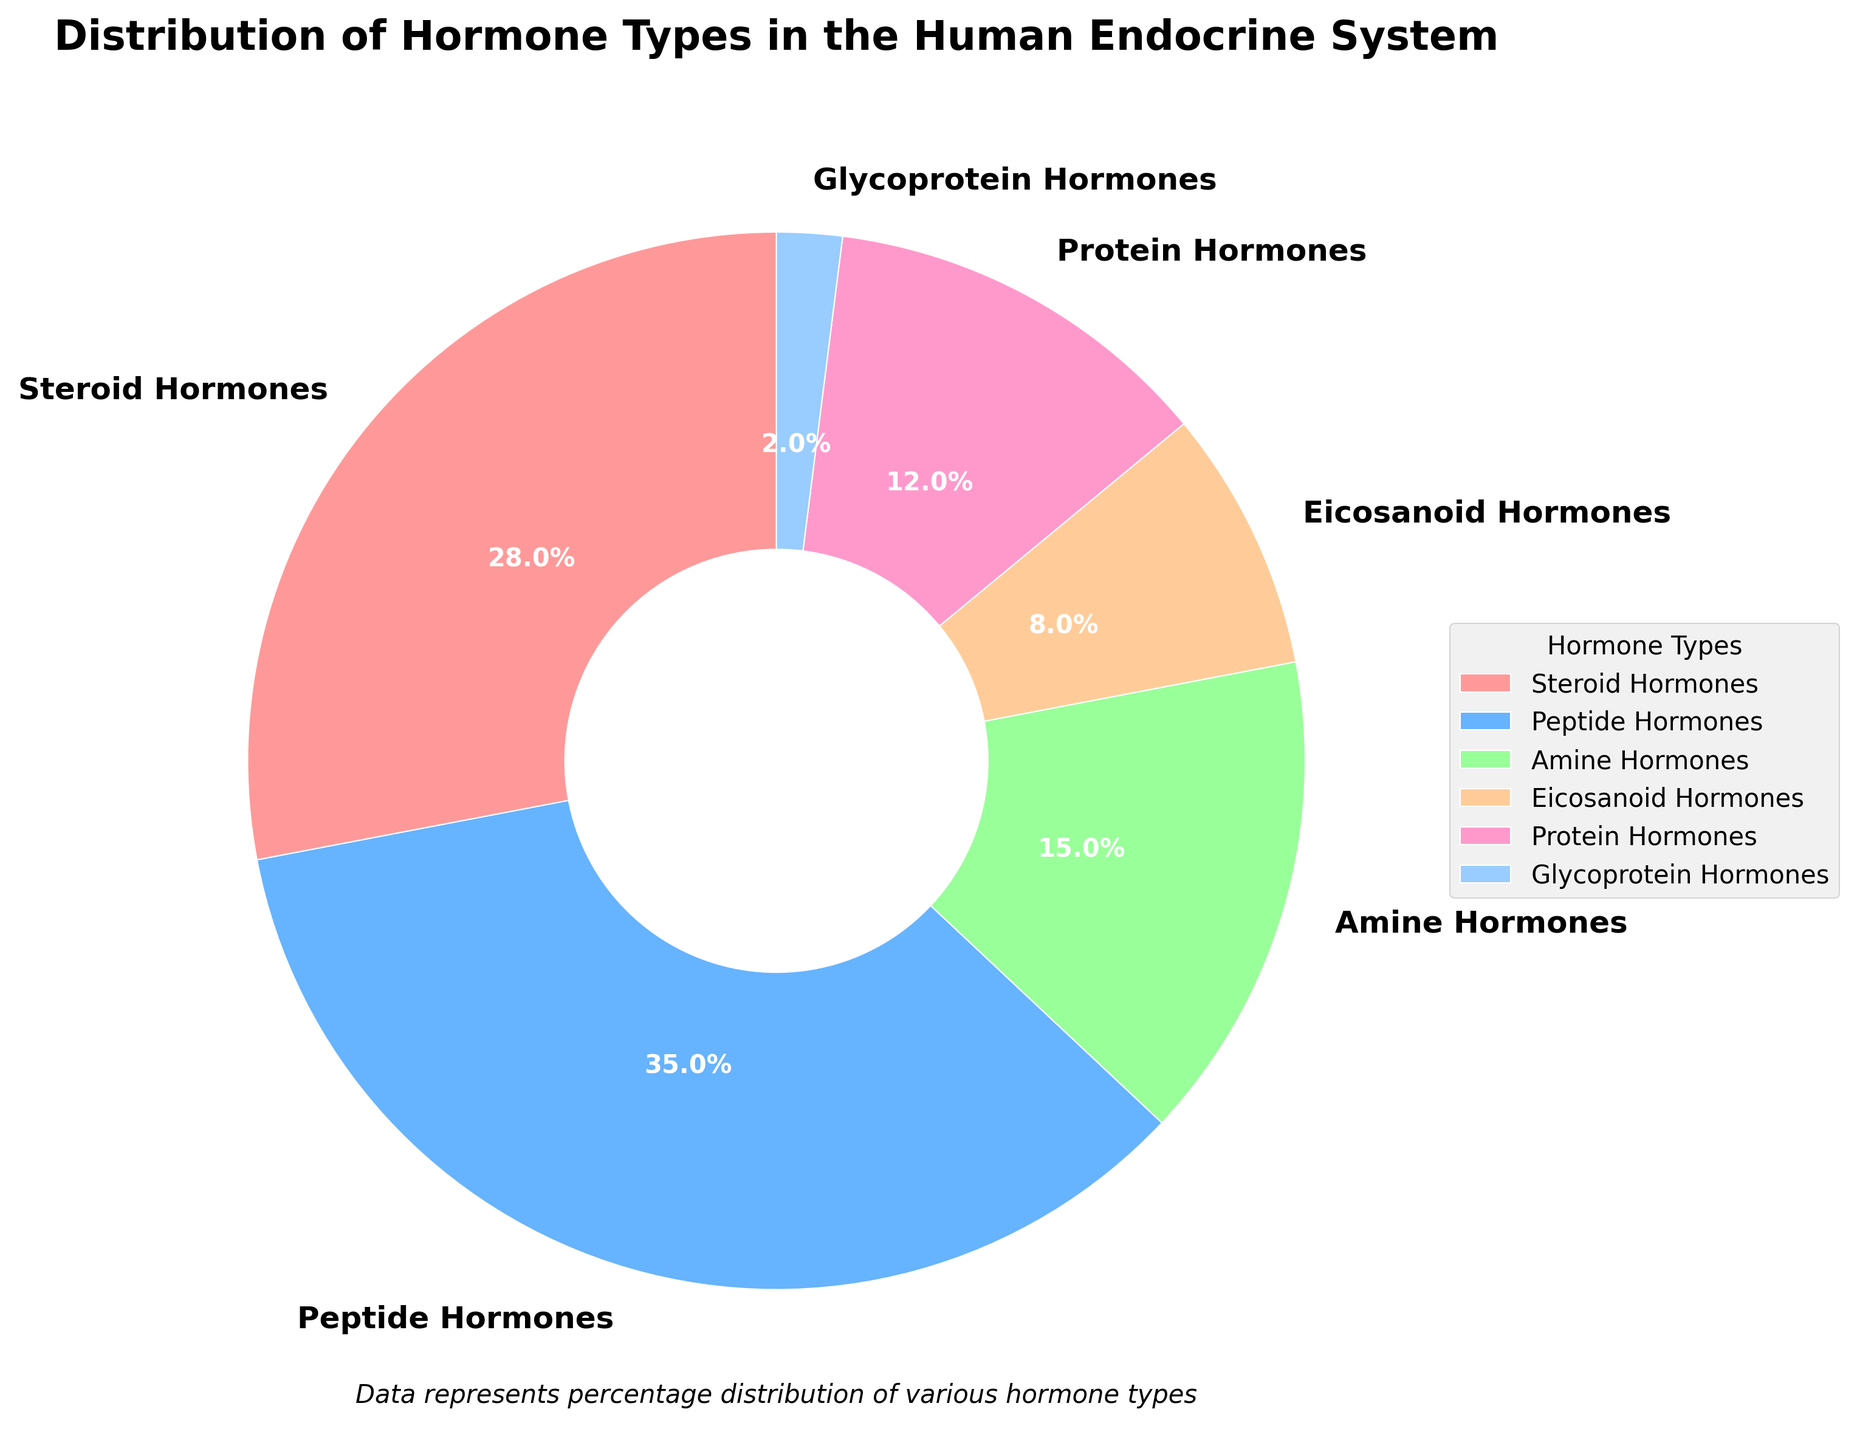Which hormone type is the most prevalent in the human endocrine system? The pie chart shows various hormone types and their percentages. Peptide Hormones have the largest slice of the pie, indicating the highest percentage among the hormone types.
Answer: Peptide Hormones Which hormone types together make up more than half of the total distribution? Adding the percentages of the hormone types to find the combination that exceeds 50%. Peptide Hormones (35%) and Steroid Hormones (28%) together make up more than half (35% + 28% = 63%).
Answer: Peptide Hormones and Steroid Hormones How does the percentage of Amine Hormones compare to that of Protein Hormones? Compare the slices of the pie chart representing Amine Hormones (15%) and Protein Hormones (12%). Amine Hormones have a slightly larger percentage than Protein Hormones.
Answer: Amine Hormones have a higher percentage than Protein Hormones Which hormone type has the smallest percentage in the distribution? The pie chart shows Glycoprotein Hormones with the smallest slice, indicating the least percentage at 2%.
Answer: Glycoprotein Hormones What is the combined percentage of Eicosanoid Hormones and Glycoprotein Hormones? Adding the percentages of Eicosanoid Hormones (8%) and Glycoprotein Hormones (2%) gives the total percentage. 8% + 2% = 10%.
Answer: 10% What is the difference in percentage between the most and least abundant hormone types? The most abundant hormone type is Peptide Hormones (35%), and the least abundant is Glycoprotein Hormones (2%). Subtract the smaller percentage from the larger one: 35% - 2% = 33%.
Answer: 33% Which hormone type is represented by the blue slice in the pie chart? The legend associated with the pie chart indicates that the blue slice represents Peptide Hormones.
Answer: Peptide Hormones What proportion of the hormone types represented are categorized as Steroid Hormones compared to Eicosanoid Hormones? By comparing the percentages, Steroid Hormones are 28% and Eicosanoid Hormones are 8%. Steroid Hormones are 28% / 8% = 3.5 times more prevalent than Eicosanoid Hormones.
Answer: Steroid Hormones are 3.5 times more prevalent than Eicosanoid Hormones How much greater is the slice representing Peptide Hormones than the slice for Protein Hormones? Comparing the percentages, Peptide Hormones (35%) and Protein Hormones (12%). 35% - 12% = 23% larger.
Answer: 23% Which hormone types collectively account for less than one-third of the distribution? Identifying hormone types with percentages adding up to less than 33%: Glycoprotein Hormones (2%), Eicosanoid Hormones (8%), and Protein Hormones (12%). Adding their percentages: 2% + 8% + 12% = 22%.
Answer: Glycoprotein Hormones, Eicosanoid Hormones, and Protein Hormones 